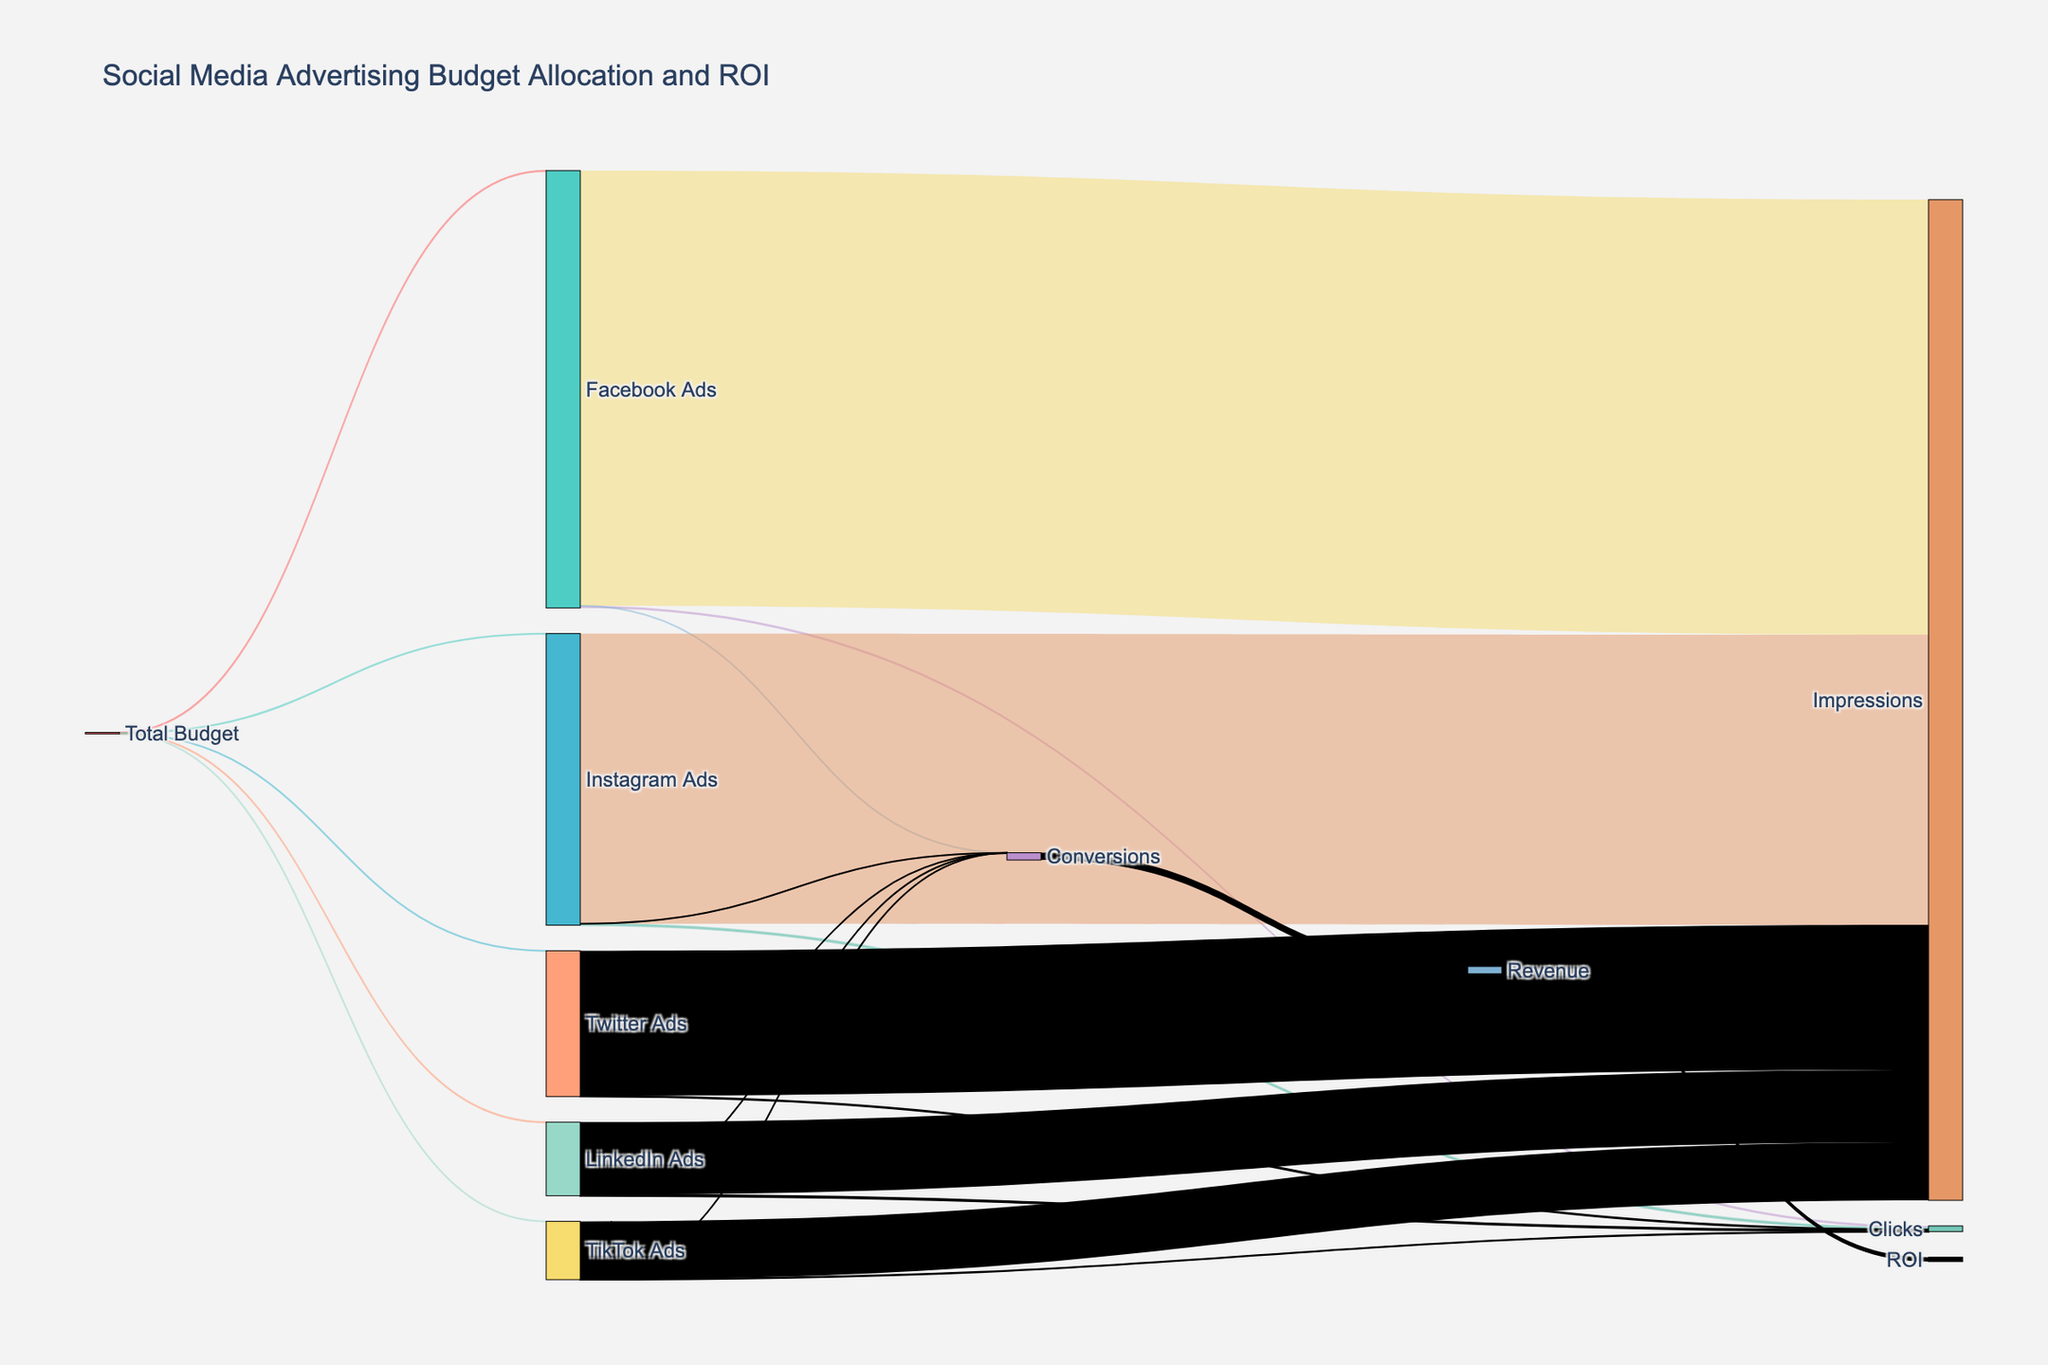what is the total budget allocated to social media advertising? The total budget is the sum of allocations to Facebook Ads, Instagram Ads, Twitter Ads, LinkedIn Ads, and TikTok Ads. Summing them up: 350000 + 250000 + 150000 + 200000 + 50000.
Answer: 1000000 how many ads impressions were generated by Twitter Ads? The number of impressions generated by Twitter Ads is represented as a flow from the Twitter Ads node to the Impressions node.
Answer: 100000000 which social media platform received the least budget allocation? To find the platform with the least budget allocation, compare the values flowing out from the Total Budget node. TikTok Ads received the smallest allocation of 50000.
Answer: TikTok Ads how many clicks in total were generated by all social media platforms combined? Sum up the clicks from Facebook Ads, Instagram Ads, Twitter Ads, LinkedIn Ads, and TikTok Ads. Calculations: 1500000 + 1000000 + 500000 + 750000 + 200000.
Answer: 3950000 how does the revenue generated from conversions relate to the total number of conversions? The revenue node receives flow just from the Conversions node. This relation indicates that all conversions directly contribute to the total revenue. The total value is shown by the node preceding revenue, representing conversions' contribution.
Answer: 5000000 what is the pad width used in the Sankey diagram? The pad width is directly provided in the attributes for the nodes in the figure generation code. The pad width used is set explicitly in the node layout.
Answer: 20 which platform has the highest number of conversions, and how many? By comparing the flow values from each platform to the Conversions node, Facebook Ads has the highest number of conversions with a total of 75000.
Answer: Facebook Ads, 75000 what is the difference in budget allocation between LinkedIn Ads and Twitter Ads? Subtract the budget allocated to Twitter Ads from that allocated to LinkedIn Ads: 200000 - 150000.
Answer: 50000 how does ROI compare to the total revenue generated from social media advertising? The ROI node receives flow directly from the Revenue node, indicating that ROI is a subset of the total revenue. The ROI value can be visually compared to the total revenue value.
Answer: 3000000 < 5000000 which social media platform has a higher number of clicks, LinkedIn Ads or Instagram Ads, and by how much? Compare the flows to the Clicks node from LinkedIn Ads and Instagram Ads. Calculations: 1000000 (Instagram) - 750000 (LinkedIn) = 250000 more clicks for Instagram Ads.
Answer: Instagram Ads, 250000 